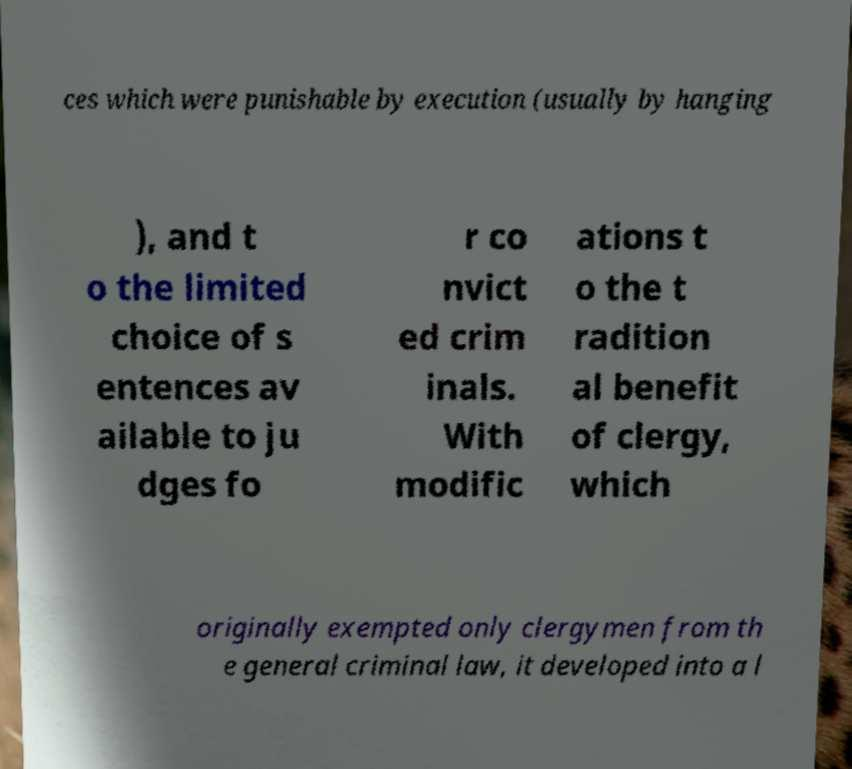Could you assist in decoding the text presented in this image and type it out clearly? ces which were punishable by execution (usually by hanging ), and t o the limited choice of s entences av ailable to ju dges fo r co nvict ed crim inals. With modific ations t o the t radition al benefit of clergy, which originally exempted only clergymen from th e general criminal law, it developed into a l 